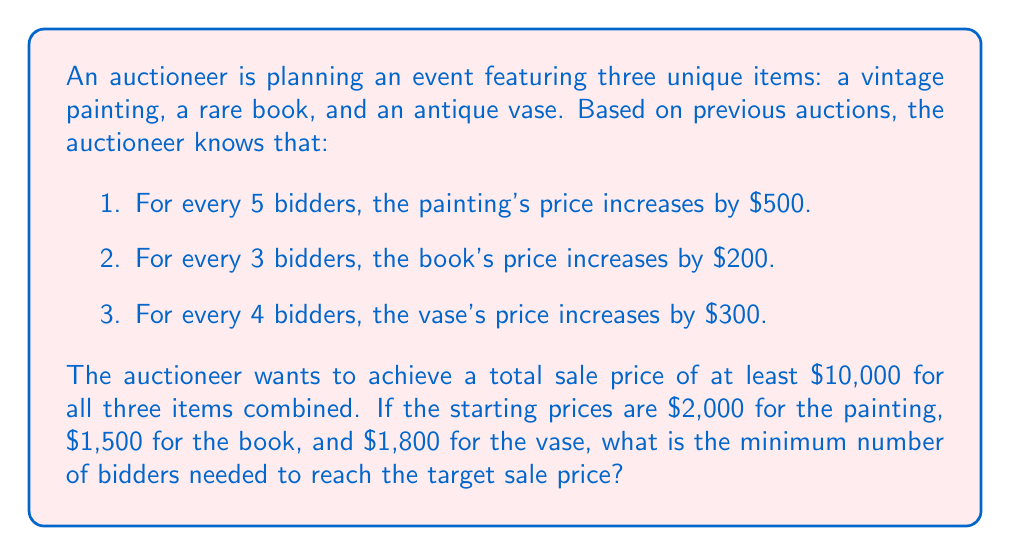Can you answer this question? Let's approach this step-by-step:

1) First, let's define our variable:
   Let $x$ be the number of bidders.

2) Now, let's create equations for each item's price based on the number of bidders:

   Painting: $P = 2000 + 500 \cdot \frac{x}{5}$
   Book: $B = 1500 + 200 \cdot \frac{x}{3}$
   Vase: $V = 1800 + 300 \cdot \frac{x}{4}$

3) The total price needs to be at least $10,000, so we can set up the inequality:

   $P + B + V \geq 10000$

4) Substituting our equations:

   $(2000 + 500 \cdot \frac{x}{5}) + (1500 + 200 \cdot \frac{x}{3}) + (1800 + 300 \cdot \frac{x}{4}) \geq 10000$

5) Simplify:

   $5300 + 100x + 66.67x + 75x \geq 10000$

6) Combine like terms:

   $5300 + 241.67x \geq 10000$

7) Subtract 5300 from both sides:

   $241.67x \geq 4700$

8) Divide both sides by 241.67:

   $x \geq 19.45$

9) Since we need a whole number of bidders, we round up to the next integer.
Answer: The minimum number of bidders needed is 20. 